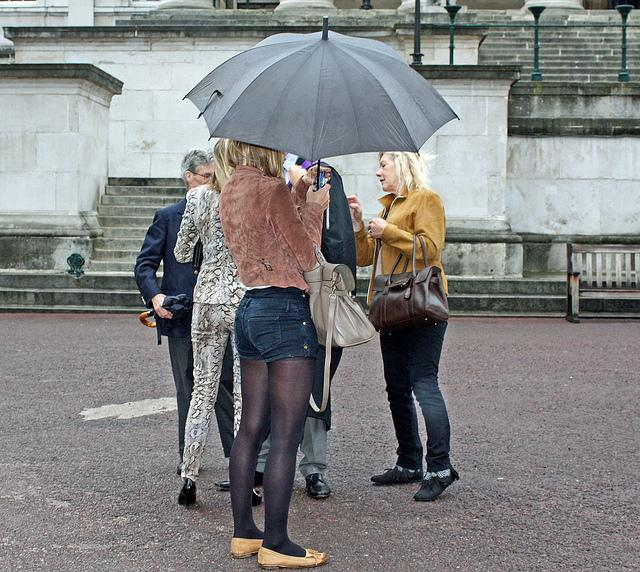From what materials is the wall made? Please explain your reasoning. blocks. The wall has several sections that look like they are stacked up like bricks. 